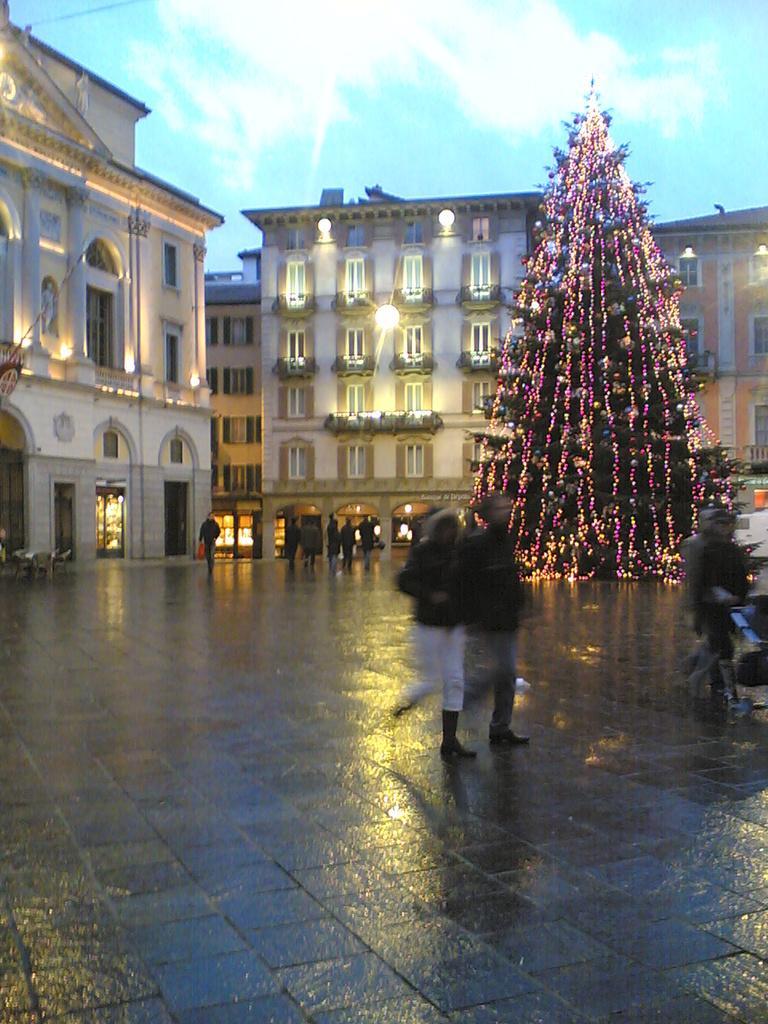How would you summarize this image in a sentence or two? This image consists of buildings in the middle. There is a Christmas tree on the right side. There are some persons in the middle. There is sky at the top. 